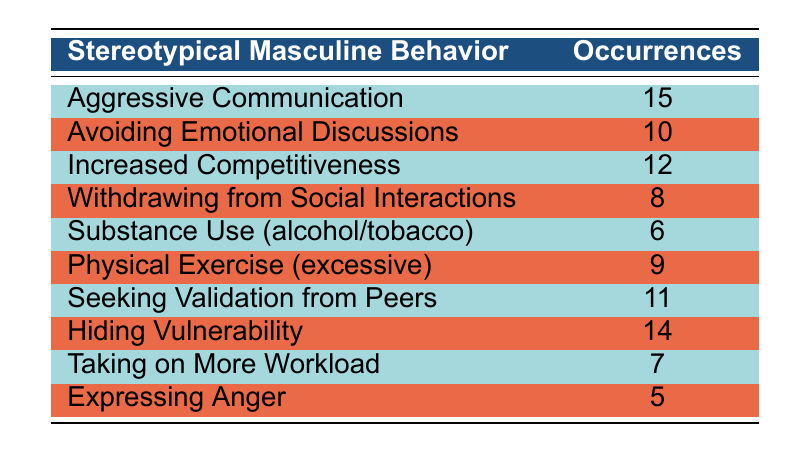What is the most frequently occurring stereotypical masculine behavior? The table shows the occurrences for each behavior. "Aggressive Communication" has the highest number of occurrences, which is 15.
Answer: 15 How many behaviors have occurrences between 8 and 12? Checking the table, the behaviors with occurrences in this range are "Increased Competitiveness" (12), "Avoiding Emotional Discussions" (10), and "Physical Exercise (excessive)" (9). That's a total of 3 behaviors.
Answer: 3 Is "Expressing Anger" the behavior with the least occurrences? The table indicates that "Expressing Anger" has 5 occurrences, which is indeed the lowest when compared to all other behaviors listed.
Answer: Yes What is the difference in occurrences between "Hiding Vulnerability" and "Substance Use (alcohol/tobacco)"? "Hiding Vulnerability" has 14 occurrences, and "Substance Use (alcohol/tobacco)" has 6 occurrences. The difference here is 14 - 6 = 8.
Answer: 8 What percentage of the total occurrences is attributed to "Seeking Validation from Peers"? First, we need to calculate the total occurrences by summing all the behaviors: 15 + 10 + 12 + 8 + 6 + 9 + 11 + 14 + 7 + 5 = 87. "Seeking Validation from Peers" has 11 occurrences. Therefore, the percentage is (11 / 87) * 100 ≈ 12.64%.
Answer: 12.64% 